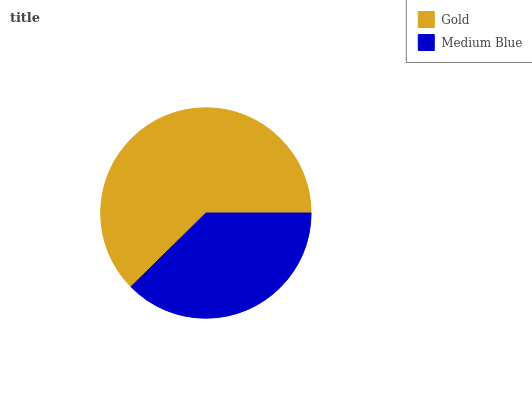Is Medium Blue the minimum?
Answer yes or no. Yes. Is Gold the maximum?
Answer yes or no. Yes. Is Medium Blue the maximum?
Answer yes or no. No. Is Gold greater than Medium Blue?
Answer yes or no. Yes. Is Medium Blue less than Gold?
Answer yes or no. Yes. Is Medium Blue greater than Gold?
Answer yes or no. No. Is Gold less than Medium Blue?
Answer yes or no. No. Is Gold the high median?
Answer yes or no. Yes. Is Medium Blue the low median?
Answer yes or no. Yes. Is Medium Blue the high median?
Answer yes or no. No. Is Gold the low median?
Answer yes or no. No. 